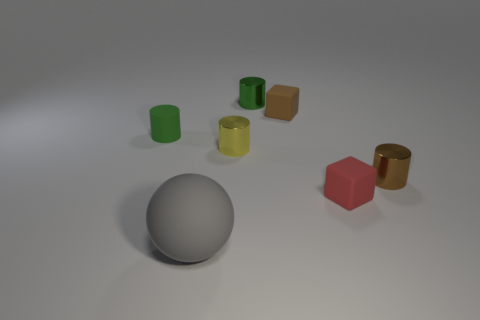Subtract all cyan blocks. How many green cylinders are left? 2 Subtract all brown cylinders. How many cylinders are left? 3 Add 3 tiny red matte objects. How many objects exist? 10 Subtract all brown cylinders. How many cylinders are left? 3 Subtract 0 purple cylinders. How many objects are left? 7 Subtract all blocks. How many objects are left? 5 Subtract 1 cylinders. How many cylinders are left? 3 Subtract all blue balls. Subtract all yellow cylinders. How many balls are left? 1 Subtract all gray rubber objects. Subtract all yellow objects. How many objects are left? 5 Add 1 red blocks. How many red blocks are left? 2 